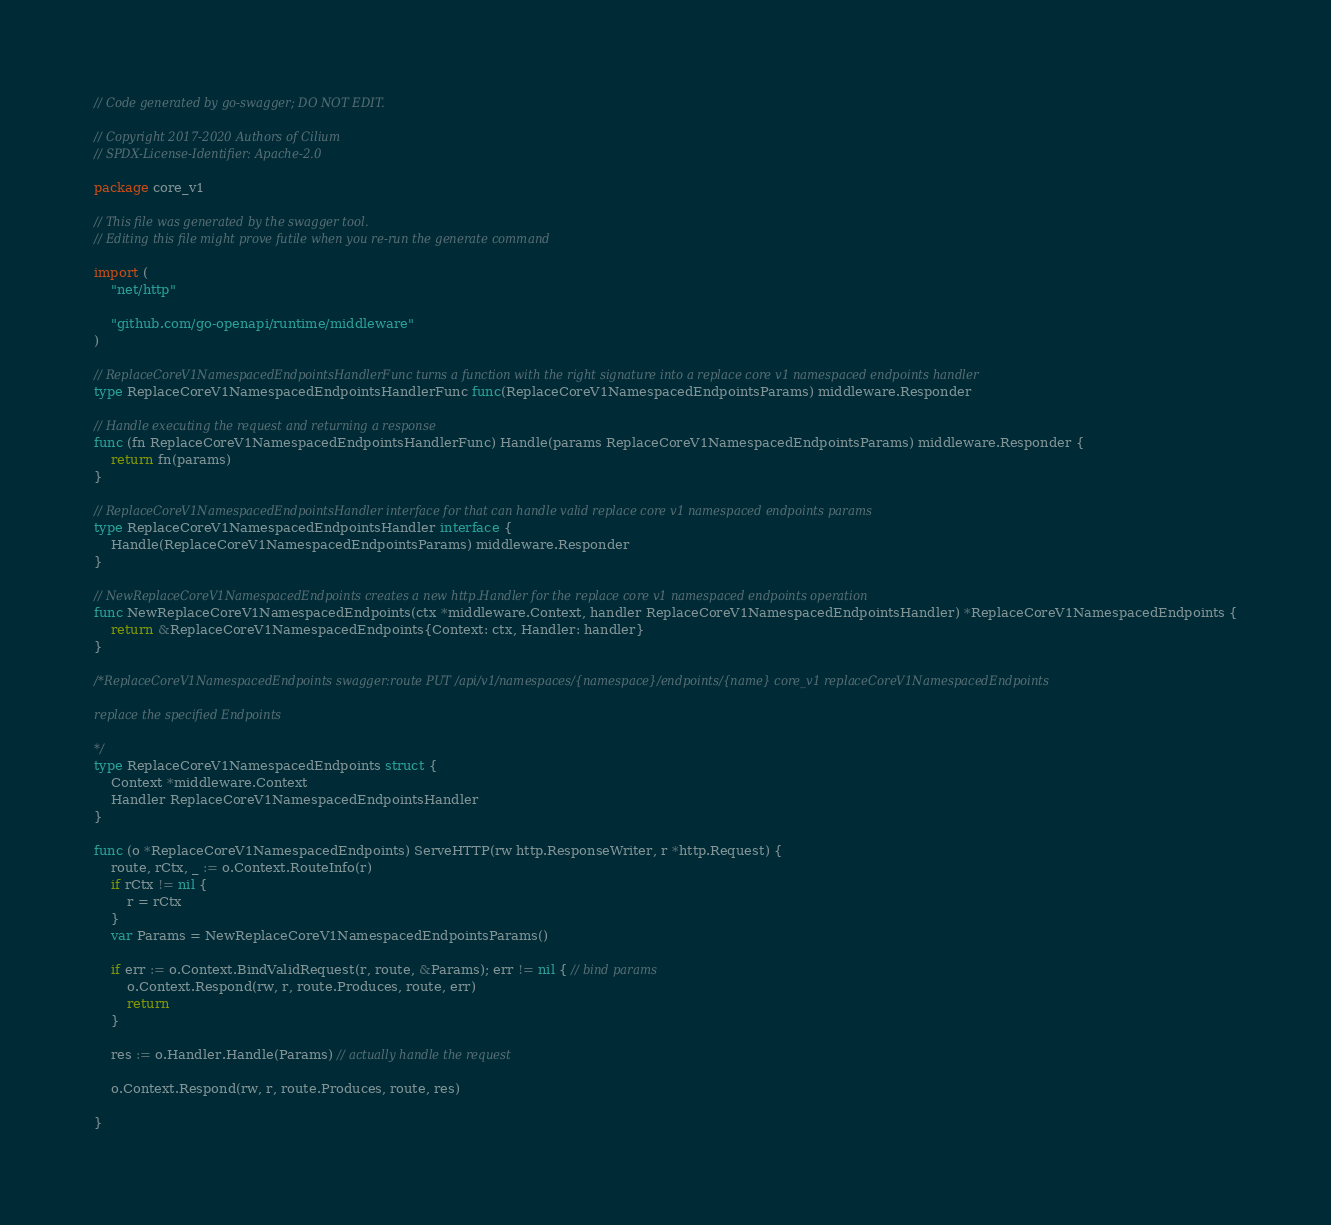<code> <loc_0><loc_0><loc_500><loc_500><_Go_>// Code generated by go-swagger; DO NOT EDIT.

// Copyright 2017-2020 Authors of Cilium
// SPDX-License-Identifier: Apache-2.0

package core_v1

// This file was generated by the swagger tool.
// Editing this file might prove futile when you re-run the generate command

import (
	"net/http"

	"github.com/go-openapi/runtime/middleware"
)

// ReplaceCoreV1NamespacedEndpointsHandlerFunc turns a function with the right signature into a replace core v1 namespaced endpoints handler
type ReplaceCoreV1NamespacedEndpointsHandlerFunc func(ReplaceCoreV1NamespacedEndpointsParams) middleware.Responder

// Handle executing the request and returning a response
func (fn ReplaceCoreV1NamespacedEndpointsHandlerFunc) Handle(params ReplaceCoreV1NamespacedEndpointsParams) middleware.Responder {
	return fn(params)
}

// ReplaceCoreV1NamespacedEndpointsHandler interface for that can handle valid replace core v1 namespaced endpoints params
type ReplaceCoreV1NamespacedEndpointsHandler interface {
	Handle(ReplaceCoreV1NamespacedEndpointsParams) middleware.Responder
}

// NewReplaceCoreV1NamespacedEndpoints creates a new http.Handler for the replace core v1 namespaced endpoints operation
func NewReplaceCoreV1NamespacedEndpoints(ctx *middleware.Context, handler ReplaceCoreV1NamespacedEndpointsHandler) *ReplaceCoreV1NamespacedEndpoints {
	return &ReplaceCoreV1NamespacedEndpoints{Context: ctx, Handler: handler}
}

/*ReplaceCoreV1NamespacedEndpoints swagger:route PUT /api/v1/namespaces/{namespace}/endpoints/{name} core_v1 replaceCoreV1NamespacedEndpoints

replace the specified Endpoints

*/
type ReplaceCoreV1NamespacedEndpoints struct {
	Context *middleware.Context
	Handler ReplaceCoreV1NamespacedEndpointsHandler
}

func (o *ReplaceCoreV1NamespacedEndpoints) ServeHTTP(rw http.ResponseWriter, r *http.Request) {
	route, rCtx, _ := o.Context.RouteInfo(r)
	if rCtx != nil {
		r = rCtx
	}
	var Params = NewReplaceCoreV1NamespacedEndpointsParams()

	if err := o.Context.BindValidRequest(r, route, &Params); err != nil { // bind params
		o.Context.Respond(rw, r, route.Produces, route, err)
		return
	}

	res := o.Handler.Handle(Params) // actually handle the request

	o.Context.Respond(rw, r, route.Produces, route, res)

}
</code> 